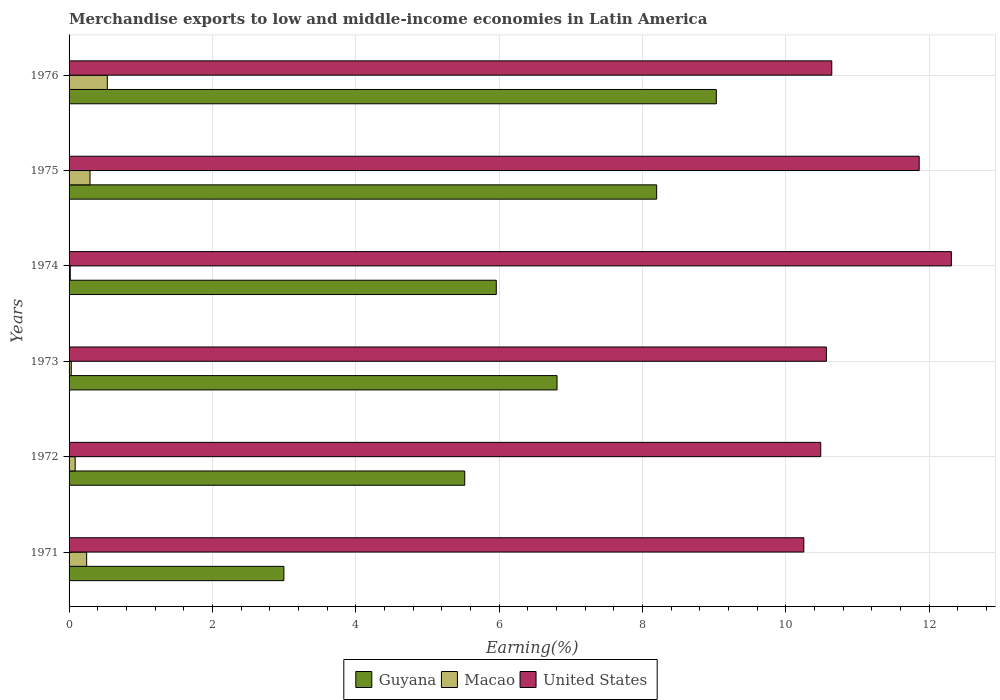Are the number of bars per tick equal to the number of legend labels?
Keep it short and to the point. Yes. How many bars are there on the 2nd tick from the top?
Offer a very short reply. 3. How many bars are there on the 3rd tick from the bottom?
Your answer should be compact. 3. What is the label of the 1st group of bars from the top?
Your response must be concise. 1976. In how many cases, is the number of bars for a given year not equal to the number of legend labels?
Provide a short and direct response. 0. What is the percentage of amount earned from merchandise exports in United States in 1974?
Your answer should be compact. 12.31. Across all years, what is the maximum percentage of amount earned from merchandise exports in Macao?
Give a very brief answer. 0.53. Across all years, what is the minimum percentage of amount earned from merchandise exports in United States?
Offer a terse response. 10.25. In which year was the percentage of amount earned from merchandise exports in Guyana maximum?
Provide a short and direct response. 1976. In which year was the percentage of amount earned from merchandise exports in Guyana minimum?
Give a very brief answer. 1971. What is the total percentage of amount earned from merchandise exports in Guyana in the graph?
Your response must be concise. 38.52. What is the difference between the percentage of amount earned from merchandise exports in Macao in 1973 and that in 1975?
Your response must be concise. -0.26. What is the difference between the percentage of amount earned from merchandise exports in Guyana in 1973 and the percentage of amount earned from merchandise exports in Macao in 1976?
Make the answer very short. 6.28. What is the average percentage of amount earned from merchandise exports in Macao per year?
Provide a short and direct response. 0.2. In the year 1975, what is the difference between the percentage of amount earned from merchandise exports in Guyana and percentage of amount earned from merchandise exports in Macao?
Offer a terse response. 7.91. In how many years, is the percentage of amount earned from merchandise exports in United States greater than 12 %?
Give a very brief answer. 1. What is the ratio of the percentage of amount earned from merchandise exports in Guyana in 1971 to that in 1974?
Give a very brief answer. 0.5. Is the percentage of amount earned from merchandise exports in Guyana in 1973 less than that in 1975?
Give a very brief answer. Yes. What is the difference between the highest and the second highest percentage of amount earned from merchandise exports in Macao?
Provide a succinct answer. 0.24. What is the difference between the highest and the lowest percentage of amount earned from merchandise exports in Guyana?
Provide a short and direct response. 6.03. What does the 3rd bar from the top in 1971 represents?
Your answer should be compact. Guyana. What does the 2nd bar from the bottom in 1974 represents?
Your answer should be compact. Macao. Is it the case that in every year, the sum of the percentage of amount earned from merchandise exports in Guyana and percentage of amount earned from merchandise exports in Macao is greater than the percentage of amount earned from merchandise exports in United States?
Make the answer very short. No. How many bars are there?
Offer a very short reply. 18. How many years are there in the graph?
Provide a succinct answer. 6. Are the values on the major ticks of X-axis written in scientific E-notation?
Your answer should be compact. No. Does the graph contain grids?
Make the answer very short. Yes. How many legend labels are there?
Provide a succinct answer. 3. How are the legend labels stacked?
Provide a short and direct response. Horizontal. What is the title of the graph?
Ensure brevity in your answer.  Merchandise exports to low and middle-income economies in Latin America. What is the label or title of the X-axis?
Provide a succinct answer. Earning(%). What is the label or title of the Y-axis?
Offer a very short reply. Years. What is the Earning(%) in Guyana in 1971?
Make the answer very short. 3. What is the Earning(%) in Macao in 1971?
Ensure brevity in your answer.  0.25. What is the Earning(%) of United States in 1971?
Offer a terse response. 10.25. What is the Earning(%) of Guyana in 1972?
Make the answer very short. 5.52. What is the Earning(%) in Macao in 1972?
Offer a terse response. 0.09. What is the Earning(%) of United States in 1972?
Provide a short and direct response. 10.49. What is the Earning(%) in Guyana in 1973?
Your answer should be compact. 6.81. What is the Earning(%) of Macao in 1973?
Your answer should be compact. 0.03. What is the Earning(%) of United States in 1973?
Provide a succinct answer. 10.57. What is the Earning(%) of Guyana in 1974?
Ensure brevity in your answer.  5.96. What is the Earning(%) in Macao in 1974?
Your answer should be very brief. 0.02. What is the Earning(%) in United States in 1974?
Ensure brevity in your answer.  12.31. What is the Earning(%) of Guyana in 1975?
Give a very brief answer. 8.2. What is the Earning(%) in Macao in 1975?
Make the answer very short. 0.29. What is the Earning(%) in United States in 1975?
Provide a succinct answer. 11.86. What is the Earning(%) in Guyana in 1976?
Your response must be concise. 9.03. What is the Earning(%) in Macao in 1976?
Keep it short and to the point. 0.53. What is the Earning(%) in United States in 1976?
Make the answer very short. 10.64. Across all years, what is the maximum Earning(%) of Guyana?
Give a very brief answer. 9.03. Across all years, what is the maximum Earning(%) of Macao?
Provide a short and direct response. 0.53. Across all years, what is the maximum Earning(%) of United States?
Your response must be concise. 12.31. Across all years, what is the minimum Earning(%) of Guyana?
Provide a succinct answer. 3. Across all years, what is the minimum Earning(%) of Macao?
Your answer should be very brief. 0.02. Across all years, what is the minimum Earning(%) of United States?
Offer a terse response. 10.25. What is the total Earning(%) of Guyana in the graph?
Make the answer very short. 38.52. What is the total Earning(%) of Macao in the graph?
Ensure brevity in your answer.  1.2. What is the total Earning(%) in United States in the graph?
Make the answer very short. 66.13. What is the difference between the Earning(%) in Guyana in 1971 and that in 1972?
Make the answer very short. -2.52. What is the difference between the Earning(%) in Macao in 1971 and that in 1972?
Provide a short and direct response. 0.16. What is the difference between the Earning(%) in United States in 1971 and that in 1972?
Offer a very short reply. -0.24. What is the difference between the Earning(%) of Guyana in 1971 and that in 1973?
Make the answer very short. -3.81. What is the difference between the Earning(%) in Macao in 1971 and that in 1973?
Provide a succinct answer. 0.21. What is the difference between the Earning(%) of United States in 1971 and that in 1973?
Give a very brief answer. -0.31. What is the difference between the Earning(%) in Guyana in 1971 and that in 1974?
Ensure brevity in your answer.  -2.96. What is the difference between the Earning(%) in Macao in 1971 and that in 1974?
Make the answer very short. 0.23. What is the difference between the Earning(%) in United States in 1971 and that in 1974?
Provide a succinct answer. -2.06. What is the difference between the Earning(%) in Guyana in 1971 and that in 1975?
Provide a succinct answer. -5.2. What is the difference between the Earning(%) of Macao in 1971 and that in 1975?
Offer a terse response. -0.05. What is the difference between the Earning(%) in United States in 1971 and that in 1975?
Provide a succinct answer. -1.61. What is the difference between the Earning(%) of Guyana in 1971 and that in 1976?
Your response must be concise. -6.03. What is the difference between the Earning(%) in Macao in 1971 and that in 1976?
Give a very brief answer. -0.29. What is the difference between the Earning(%) of United States in 1971 and that in 1976?
Your answer should be very brief. -0.39. What is the difference between the Earning(%) in Guyana in 1972 and that in 1973?
Your answer should be compact. -1.29. What is the difference between the Earning(%) of Macao in 1972 and that in 1973?
Offer a very short reply. 0.05. What is the difference between the Earning(%) of United States in 1972 and that in 1973?
Provide a succinct answer. -0.08. What is the difference between the Earning(%) of Guyana in 1972 and that in 1974?
Give a very brief answer. -0.44. What is the difference between the Earning(%) in Macao in 1972 and that in 1974?
Make the answer very short. 0.07. What is the difference between the Earning(%) in United States in 1972 and that in 1974?
Your response must be concise. -1.82. What is the difference between the Earning(%) of Guyana in 1972 and that in 1975?
Give a very brief answer. -2.68. What is the difference between the Earning(%) in Macao in 1972 and that in 1975?
Give a very brief answer. -0.21. What is the difference between the Earning(%) in United States in 1972 and that in 1975?
Your answer should be very brief. -1.37. What is the difference between the Earning(%) in Guyana in 1972 and that in 1976?
Offer a terse response. -3.51. What is the difference between the Earning(%) in Macao in 1972 and that in 1976?
Your answer should be compact. -0.45. What is the difference between the Earning(%) of United States in 1972 and that in 1976?
Offer a very short reply. -0.15. What is the difference between the Earning(%) of Guyana in 1973 and that in 1974?
Provide a succinct answer. 0.85. What is the difference between the Earning(%) of Macao in 1973 and that in 1974?
Give a very brief answer. 0.01. What is the difference between the Earning(%) of United States in 1973 and that in 1974?
Make the answer very short. -1.74. What is the difference between the Earning(%) in Guyana in 1973 and that in 1975?
Provide a short and direct response. -1.39. What is the difference between the Earning(%) in Macao in 1973 and that in 1975?
Offer a very short reply. -0.26. What is the difference between the Earning(%) of United States in 1973 and that in 1975?
Offer a very short reply. -1.29. What is the difference between the Earning(%) in Guyana in 1973 and that in 1976?
Offer a very short reply. -2.22. What is the difference between the Earning(%) of Macao in 1973 and that in 1976?
Ensure brevity in your answer.  -0.5. What is the difference between the Earning(%) in United States in 1973 and that in 1976?
Your response must be concise. -0.08. What is the difference between the Earning(%) in Guyana in 1974 and that in 1975?
Your answer should be compact. -2.24. What is the difference between the Earning(%) of Macao in 1974 and that in 1975?
Make the answer very short. -0.28. What is the difference between the Earning(%) in United States in 1974 and that in 1975?
Your answer should be compact. 0.45. What is the difference between the Earning(%) in Guyana in 1974 and that in 1976?
Give a very brief answer. -3.07. What is the difference between the Earning(%) in Macao in 1974 and that in 1976?
Offer a very short reply. -0.52. What is the difference between the Earning(%) of United States in 1974 and that in 1976?
Provide a succinct answer. 1.67. What is the difference between the Earning(%) in Guyana in 1975 and that in 1976?
Keep it short and to the point. -0.83. What is the difference between the Earning(%) in Macao in 1975 and that in 1976?
Offer a very short reply. -0.24. What is the difference between the Earning(%) of United States in 1975 and that in 1976?
Give a very brief answer. 1.22. What is the difference between the Earning(%) in Guyana in 1971 and the Earning(%) in Macao in 1972?
Offer a very short reply. 2.91. What is the difference between the Earning(%) in Guyana in 1971 and the Earning(%) in United States in 1972?
Keep it short and to the point. -7.49. What is the difference between the Earning(%) of Macao in 1971 and the Earning(%) of United States in 1972?
Provide a short and direct response. -10.24. What is the difference between the Earning(%) of Guyana in 1971 and the Earning(%) of Macao in 1973?
Your answer should be compact. 2.97. What is the difference between the Earning(%) in Guyana in 1971 and the Earning(%) in United States in 1973?
Your answer should be very brief. -7.57. What is the difference between the Earning(%) of Macao in 1971 and the Earning(%) of United States in 1973?
Provide a succinct answer. -10.32. What is the difference between the Earning(%) in Guyana in 1971 and the Earning(%) in Macao in 1974?
Offer a terse response. 2.98. What is the difference between the Earning(%) of Guyana in 1971 and the Earning(%) of United States in 1974?
Keep it short and to the point. -9.31. What is the difference between the Earning(%) of Macao in 1971 and the Earning(%) of United States in 1974?
Offer a terse response. -12.07. What is the difference between the Earning(%) in Guyana in 1971 and the Earning(%) in Macao in 1975?
Keep it short and to the point. 2.71. What is the difference between the Earning(%) of Guyana in 1971 and the Earning(%) of United States in 1975?
Offer a terse response. -8.87. What is the difference between the Earning(%) of Macao in 1971 and the Earning(%) of United States in 1975?
Your answer should be very brief. -11.62. What is the difference between the Earning(%) of Guyana in 1971 and the Earning(%) of Macao in 1976?
Offer a terse response. 2.46. What is the difference between the Earning(%) in Guyana in 1971 and the Earning(%) in United States in 1976?
Your answer should be very brief. -7.65. What is the difference between the Earning(%) of Macao in 1971 and the Earning(%) of United States in 1976?
Your response must be concise. -10.4. What is the difference between the Earning(%) of Guyana in 1972 and the Earning(%) of Macao in 1973?
Your answer should be very brief. 5.49. What is the difference between the Earning(%) in Guyana in 1972 and the Earning(%) in United States in 1973?
Make the answer very short. -5.05. What is the difference between the Earning(%) of Macao in 1972 and the Earning(%) of United States in 1973?
Offer a terse response. -10.48. What is the difference between the Earning(%) of Guyana in 1972 and the Earning(%) of Macao in 1974?
Your answer should be compact. 5.5. What is the difference between the Earning(%) in Guyana in 1972 and the Earning(%) in United States in 1974?
Offer a terse response. -6.79. What is the difference between the Earning(%) in Macao in 1972 and the Earning(%) in United States in 1974?
Your answer should be very brief. -12.23. What is the difference between the Earning(%) in Guyana in 1972 and the Earning(%) in Macao in 1975?
Provide a short and direct response. 5.23. What is the difference between the Earning(%) in Guyana in 1972 and the Earning(%) in United States in 1975?
Your answer should be very brief. -6.34. What is the difference between the Earning(%) of Macao in 1972 and the Earning(%) of United States in 1975?
Keep it short and to the point. -11.78. What is the difference between the Earning(%) of Guyana in 1972 and the Earning(%) of Macao in 1976?
Offer a terse response. 4.99. What is the difference between the Earning(%) in Guyana in 1972 and the Earning(%) in United States in 1976?
Make the answer very short. -5.12. What is the difference between the Earning(%) of Macao in 1972 and the Earning(%) of United States in 1976?
Your response must be concise. -10.56. What is the difference between the Earning(%) of Guyana in 1973 and the Earning(%) of Macao in 1974?
Provide a succinct answer. 6.79. What is the difference between the Earning(%) of Guyana in 1973 and the Earning(%) of United States in 1974?
Offer a terse response. -5.5. What is the difference between the Earning(%) in Macao in 1973 and the Earning(%) in United States in 1974?
Make the answer very short. -12.28. What is the difference between the Earning(%) of Guyana in 1973 and the Earning(%) of Macao in 1975?
Your answer should be compact. 6.52. What is the difference between the Earning(%) in Guyana in 1973 and the Earning(%) in United States in 1975?
Keep it short and to the point. -5.05. What is the difference between the Earning(%) of Macao in 1973 and the Earning(%) of United States in 1975?
Provide a short and direct response. -11.83. What is the difference between the Earning(%) of Guyana in 1973 and the Earning(%) of Macao in 1976?
Give a very brief answer. 6.28. What is the difference between the Earning(%) in Guyana in 1973 and the Earning(%) in United States in 1976?
Your response must be concise. -3.83. What is the difference between the Earning(%) of Macao in 1973 and the Earning(%) of United States in 1976?
Ensure brevity in your answer.  -10.61. What is the difference between the Earning(%) in Guyana in 1974 and the Earning(%) in Macao in 1975?
Your answer should be compact. 5.67. What is the difference between the Earning(%) of Guyana in 1974 and the Earning(%) of United States in 1975?
Make the answer very short. -5.9. What is the difference between the Earning(%) in Macao in 1974 and the Earning(%) in United States in 1975?
Offer a terse response. -11.85. What is the difference between the Earning(%) in Guyana in 1974 and the Earning(%) in Macao in 1976?
Give a very brief answer. 5.43. What is the difference between the Earning(%) of Guyana in 1974 and the Earning(%) of United States in 1976?
Offer a very short reply. -4.68. What is the difference between the Earning(%) in Macao in 1974 and the Earning(%) in United States in 1976?
Ensure brevity in your answer.  -10.63. What is the difference between the Earning(%) in Guyana in 1975 and the Earning(%) in Macao in 1976?
Give a very brief answer. 7.67. What is the difference between the Earning(%) in Guyana in 1975 and the Earning(%) in United States in 1976?
Offer a terse response. -2.44. What is the difference between the Earning(%) of Macao in 1975 and the Earning(%) of United States in 1976?
Your response must be concise. -10.35. What is the average Earning(%) in Guyana per year?
Offer a terse response. 6.42. What is the average Earning(%) of Macao per year?
Keep it short and to the point. 0.2. What is the average Earning(%) in United States per year?
Keep it short and to the point. 11.02. In the year 1971, what is the difference between the Earning(%) in Guyana and Earning(%) in Macao?
Your response must be concise. 2.75. In the year 1971, what is the difference between the Earning(%) of Guyana and Earning(%) of United States?
Your answer should be very brief. -7.26. In the year 1971, what is the difference between the Earning(%) of Macao and Earning(%) of United States?
Provide a short and direct response. -10.01. In the year 1972, what is the difference between the Earning(%) in Guyana and Earning(%) in Macao?
Offer a terse response. 5.44. In the year 1972, what is the difference between the Earning(%) in Guyana and Earning(%) in United States?
Offer a terse response. -4.97. In the year 1972, what is the difference between the Earning(%) in Macao and Earning(%) in United States?
Offer a very short reply. -10.4. In the year 1973, what is the difference between the Earning(%) of Guyana and Earning(%) of Macao?
Keep it short and to the point. 6.78. In the year 1973, what is the difference between the Earning(%) of Guyana and Earning(%) of United States?
Your response must be concise. -3.76. In the year 1973, what is the difference between the Earning(%) of Macao and Earning(%) of United States?
Provide a succinct answer. -10.54. In the year 1974, what is the difference between the Earning(%) of Guyana and Earning(%) of Macao?
Keep it short and to the point. 5.94. In the year 1974, what is the difference between the Earning(%) of Guyana and Earning(%) of United States?
Make the answer very short. -6.35. In the year 1974, what is the difference between the Earning(%) of Macao and Earning(%) of United States?
Keep it short and to the point. -12.29. In the year 1975, what is the difference between the Earning(%) in Guyana and Earning(%) in Macao?
Give a very brief answer. 7.91. In the year 1975, what is the difference between the Earning(%) of Guyana and Earning(%) of United States?
Keep it short and to the point. -3.66. In the year 1975, what is the difference between the Earning(%) of Macao and Earning(%) of United States?
Your answer should be compact. -11.57. In the year 1976, what is the difference between the Earning(%) in Guyana and Earning(%) in Macao?
Your response must be concise. 8.5. In the year 1976, what is the difference between the Earning(%) of Guyana and Earning(%) of United States?
Offer a very short reply. -1.61. In the year 1976, what is the difference between the Earning(%) of Macao and Earning(%) of United States?
Ensure brevity in your answer.  -10.11. What is the ratio of the Earning(%) of Guyana in 1971 to that in 1972?
Give a very brief answer. 0.54. What is the ratio of the Earning(%) in Macao in 1971 to that in 1972?
Make the answer very short. 2.88. What is the ratio of the Earning(%) in United States in 1971 to that in 1972?
Your answer should be compact. 0.98. What is the ratio of the Earning(%) of Guyana in 1971 to that in 1973?
Offer a very short reply. 0.44. What is the ratio of the Earning(%) in Macao in 1971 to that in 1973?
Give a very brief answer. 8.01. What is the ratio of the Earning(%) in United States in 1971 to that in 1973?
Ensure brevity in your answer.  0.97. What is the ratio of the Earning(%) of Guyana in 1971 to that in 1974?
Give a very brief answer. 0.5. What is the ratio of the Earning(%) of Macao in 1971 to that in 1974?
Your answer should be compact. 14.41. What is the ratio of the Earning(%) in United States in 1971 to that in 1974?
Your answer should be compact. 0.83. What is the ratio of the Earning(%) of Guyana in 1971 to that in 1975?
Make the answer very short. 0.37. What is the ratio of the Earning(%) in Macao in 1971 to that in 1975?
Make the answer very short. 0.84. What is the ratio of the Earning(%) in United States in 1971 to that in 1975?
Offer a very short reply. 0.86. What is the ratio of the Earning(%) in Guyana in 1971 to that in 1976?
Your answer should be compact. 0.33. What is the ratio of the Earning(%) in Macao in 1971 to that in 1976?
Offer a very short reply. 0.46. What is the ratio of the Earning(%) of United States in 1971 to that in 1976?
Give a very brief answer. 0.96. What is the ratio of the Earning(%) in Guyana in 1972 to that in 1973?
Your answer should be compact. 0.81. What is the ratio of the Earning(%) in Macao in 1972 to that in 1973?
Keep it short and to the point. 2.78. What is the ratio of the Earning(%) of United States in 1972 to that in 1973?
Offer a very short reply. 0.99. What is the ratio of the Earning(%) in Guyana in 1972 to that in 1974?
Provide a short and direct response. 0.93. What is the ratio of the Earning(%) of Macao in 1972 to that in 1974?
Keep it short and to the point. 5. What is the ratio of the Earning(%) in United States in 1972 to that in 1974?
Your answer should be very brief. 0.85. What is the ratio of the Earning(%) in Guyana in 1972 to that in 1975?
Provide a short and direct response. 0.67. What is the ratio of the Earning(%) in Macao in 1972 to that in 1975?
Offer a terse response. 0.29. What is the ratio of the Earning(%) of United States in 1972 to that in 1975?
Provide a short and direct response. 0.88. What is the ratio of the Earning(%) in Guyana in 1972 to that in 1976?
Provide a succinct answer. 0.61. What is the ratio of the Earning(%) in Macao in 1972 to that in 1976?
Make the answer very short. 0.16. What is the ratio of the Earning(%) of United States in 1972 to that in 1976?
Offer a terse response. 0.99. What is the ratio of the Earning(%) of Guyana in 1973 to that in 1974?
Provide a short and direct response. 1.14. What is the ratio of the Earning(%) in Macao in 1973 to that in 1974?
Keep it short and to the point. 1.8. What is the ratio of the Earning(%) in United States in 1973 to that in 1974?
Ensure brevity in your answer.  0.86. What is the ratio of the Earning(%) in Guyana in 1973 to that in 1975?
Provide a short and direct response. 0.83. What is the ratio of the Earning(%) of Macao in 1973 to that in 1975?
Give a very brief answer. 0.1. What is the ratio of the Earning(%) in United States in 1973 to that in 1975?
Make the answer very short. 0.89. What is the ratio of the Earning(%) in Guyana in 1973 to that in 1976?
Make the answer very short. 0.75. What is the ratio of the Earning(%) in Macao in 1973 to that in 1976?
Keep it short and to the point. 0.06. What is the ratio of the Earning(%) of United States in 1973 to that in 1976?
Give a very brief answer. 0.99. What is the ratio of the Earning(%) of Guyana in 1974 to that in 1975?
Your answer should be compact. 0.73. What is the ratio of the Earning(%) of Macao in 1974 to that in 1975?
Your answer should be compact. 0.06. What is the ratio of the Earning(%) of United States in 1974 to that in 1975?
Provide a short and direct response. 1.04. What is the ratio of the Earning(%) of Guyana in 1974 to that in 1976?
Provide a short and direct response. 0.66. What is the ratio of the Earning(%) in Macao in 1974 to that in 1976?
Offer a very short reply. 0.03. What is the ratio of the Earning(%) in United States in 1974 to that in 1976?
Offer a terse response. 1.16. What is the ratio of the Earning(%) in Guyana in 1975 to that in 1976?
Offer a terse response. 0.91. What is the ratio of the Earning(%) in Macao in 1975 to that in 1976?
Your answer should be compact. 0.55. What is the ratio of the Earning(%) of United States in 1975 to that in 1976?
Keep it short and to the point. 1.11. What is the difference between the highest and the second highest Earning(%) of Guyana?
Make the answer very short. 0.83. What is the difference between the highest and the second highest Earning(%) in Macao?
Keep it short and to the point. 0.24. What is the difference between the highest and the second highest Earning(%) of United States?
Your response must be concise. 0.45. What is the difference between the highest and the lowest Earning(%) of Guyana?
Provide a short and direct response. 6.03. What is the difference between the highest and the lowest Earning(%) in Macao?
Keep it short and to the point. 0.52. What is the difference between the highest and the lowest Earning(%) in United States?
Your response must be concise. 2.06. 